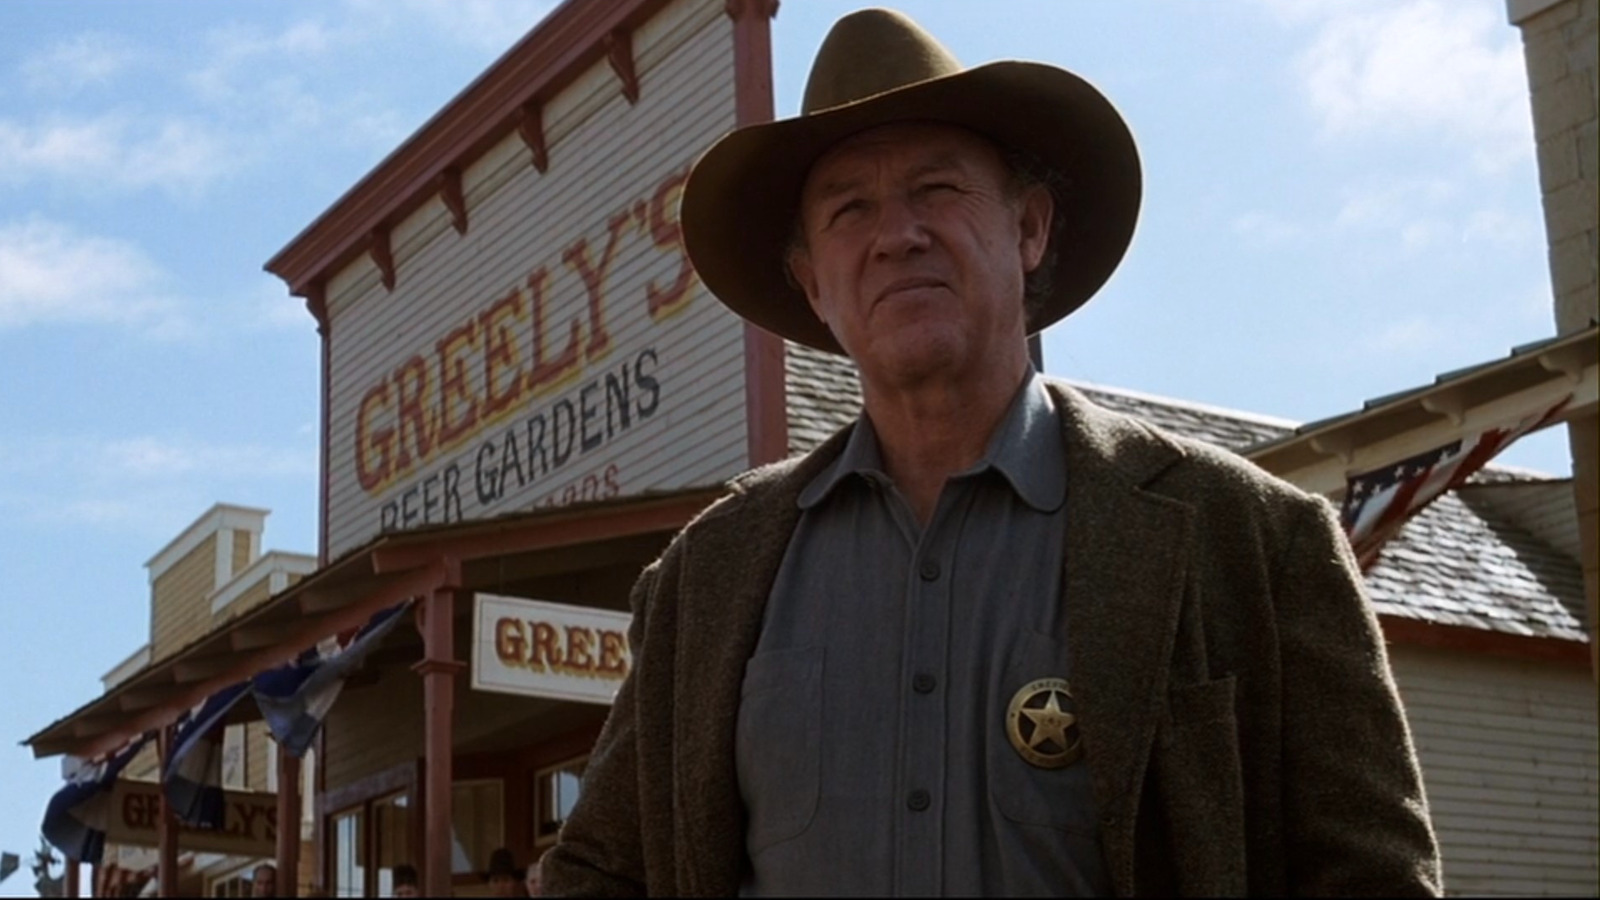Given the detailed backdrop, could you write a short yet thrilling narrative on what happens next? As the camera focuses on Sheriff Greeley's determined face, a tense silence falls over 'Greeley's Beer Gardens.' The townsfolk scatter, seeking shelter inside. Suddenly, the sound of hooves echoes down the dusty street as the outlaws approach. A fierce standoff ensues, with Greeley single-handedly facing the gang. His commanding voice cuts through the tension as he demands they leave peacefully. After a moment's hesitation, the leader draws his weapon. In a split second, Greeley’s sharp reflexes come into play, and with precision, he disarms the outlaw, asserting his control and restoring peace to Dry Creek. The sheriff’s bravery and swift action become the stuff of legends in the town’s history. 